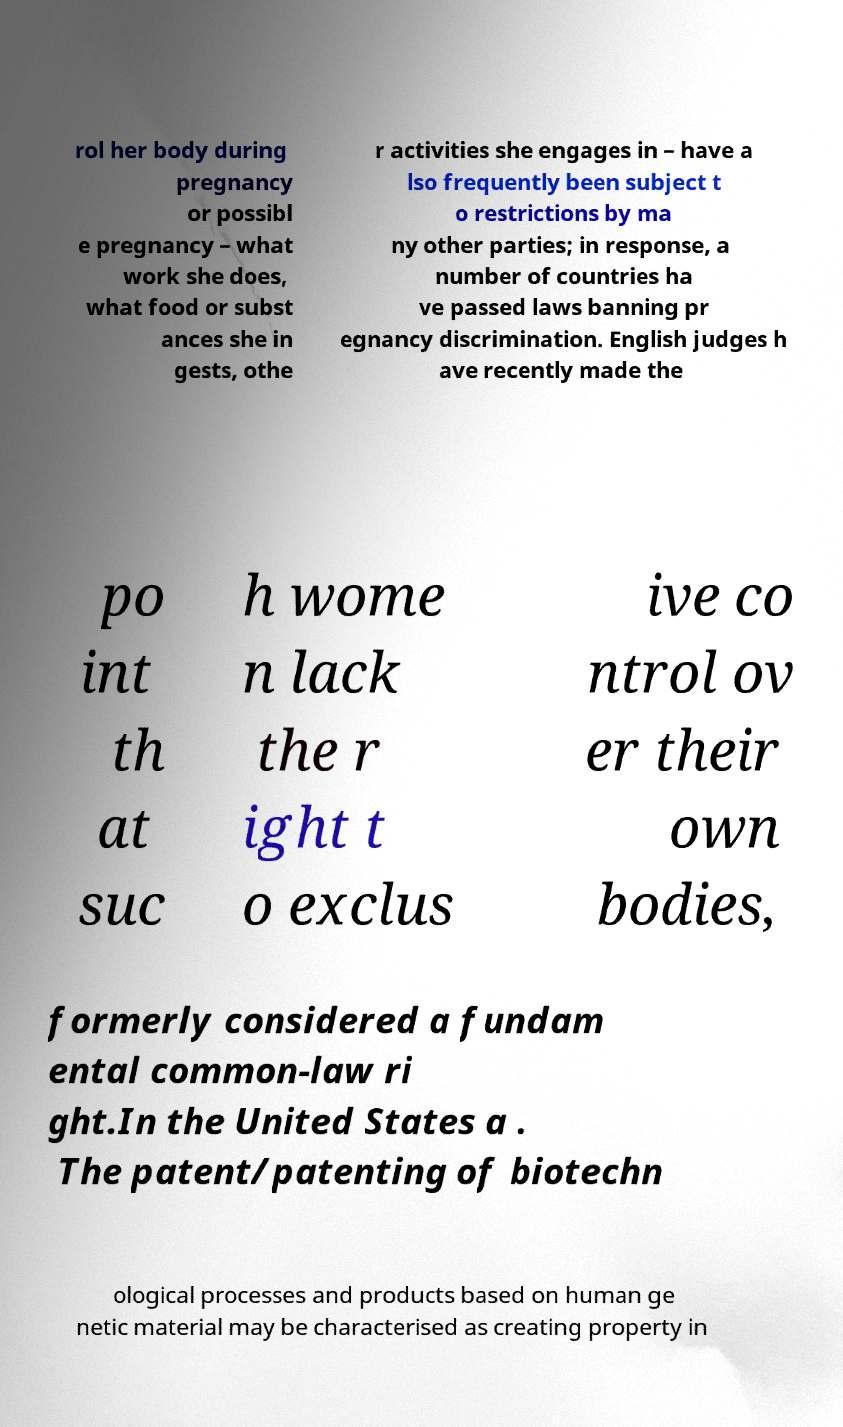I need the written content from this picture converted into text. Can you do that? rol her body during pregnancy or possibl e pregnancy – what work she does, what food or subst ances she in gests, othe r activities she engages in – have a lso frequently been subject t o restrictions by ma ny other parties; in response, a number of countries ha ve passed laws banning pr egnancy discrimination. English judges h ave recently made the po int th at suc h wome n lack the r ight t o exclus ive co ntrol ov er their own bodies, formerly considered a fundam ental common-law ri ght.In the United States a . The patent/patenting of biotechn ological processes and products based on human ge netic material may be characterised as creating property in 